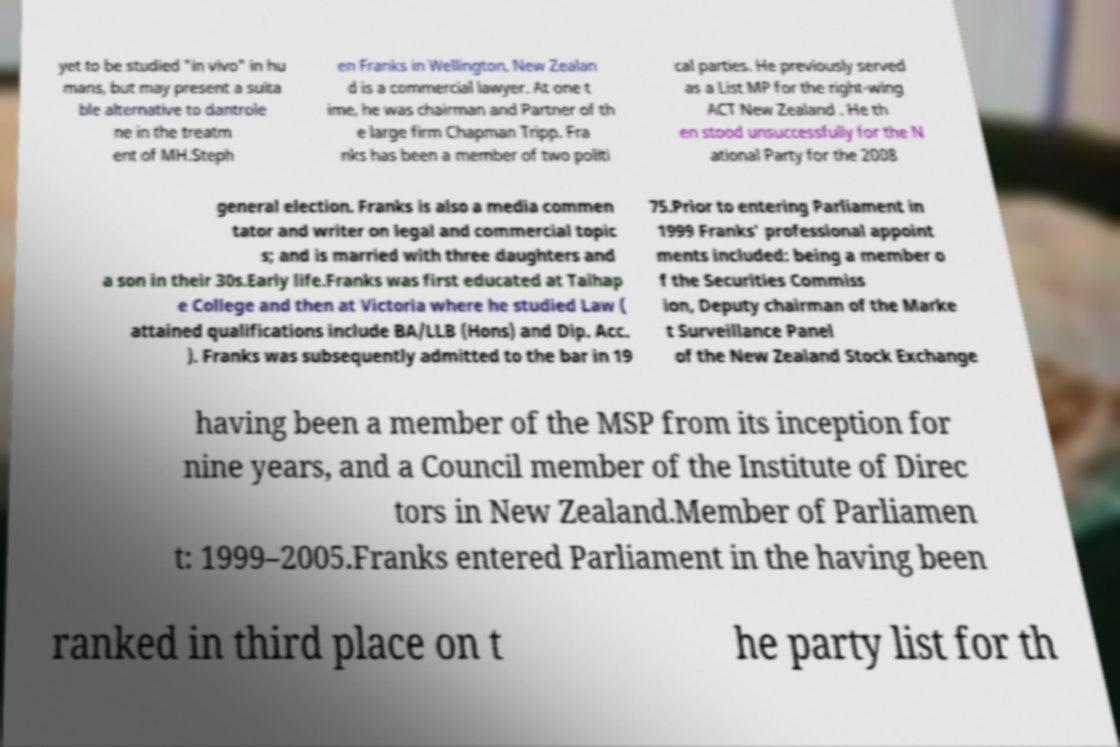What messages or text are displayed in this image? I need them in a readable, typed format. yet to be studied "in vivo" in hu mans, but may present a suita ble alternative to dantrole ne in the treatm ent of MH.Steph en Franks in Wellington, New Zealan d is a commercial lawyer. At one t ime, he was chairman and Partner of th e large firm Chapman Tripp. Fra nks has been a member of two politi cal parties. He previously served as a List MP for the right-wing ACT New Zealand . He th en stood unsuccessfully for the N ational Party for the 2008 general election. Franks is also a media commen tator and writer on legal and commercial topic s; and is married with three daughters and a son in their 30s.Early life.Franks was first educated at Taihap e College and then at Victoria where he studied Law ( attained qualifications include BA/LLB (Hons) and Dip. Acc. ). Franks was subsequently admitted to the bar in 19 75.Prior to entering Parliament in 1999 Franks' professional appoint ments included: being a member o f the Securities Commiss ion, Deputy chairman of the Marke t Surveillance Panel of the New Zealand Stock Exchange having been a member of the MSP from its inception for nine years, and a Council member of the Institute of Direc tors in New Zealand.Member of Parliamen t: 1999–2005.Franks entered Parliament in the having been ranked in third place on t he party list for th 